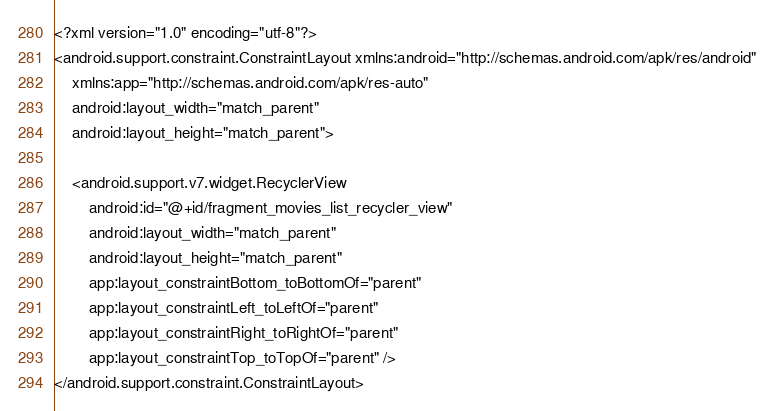Convert code to text. <code><loc_0><loc_0><loc_500><loc_500><_XML_><?xml version="1.0" encoding="utf-8"?>
<android.support.constraint.ConstraintLayout xmlns:android="http://schemas.android.com/apk/res/android"
    xmlns:app="http://schemas.android.com/apk/res-auto"
    android:layout_width="match_parent"
    android:layout_height="match_parent">

    <android.support.v7.widget.RecyclerView
        android:id="@+id/fragment_movies_list_recycler_view"
        android:layout_width="match_parent"
        android:layout_height="match_parent"
        app:layout_constraintBottom_toBottomOf="parent"
        app:layout_constraintLeft_toLeftOf="parent"
        app:layout_constraintRight_toRightOf="parent"
        app:layout_constraintTop_toTopOf="parent" />
</android.support.constraint.ConstraintLayout></code> 